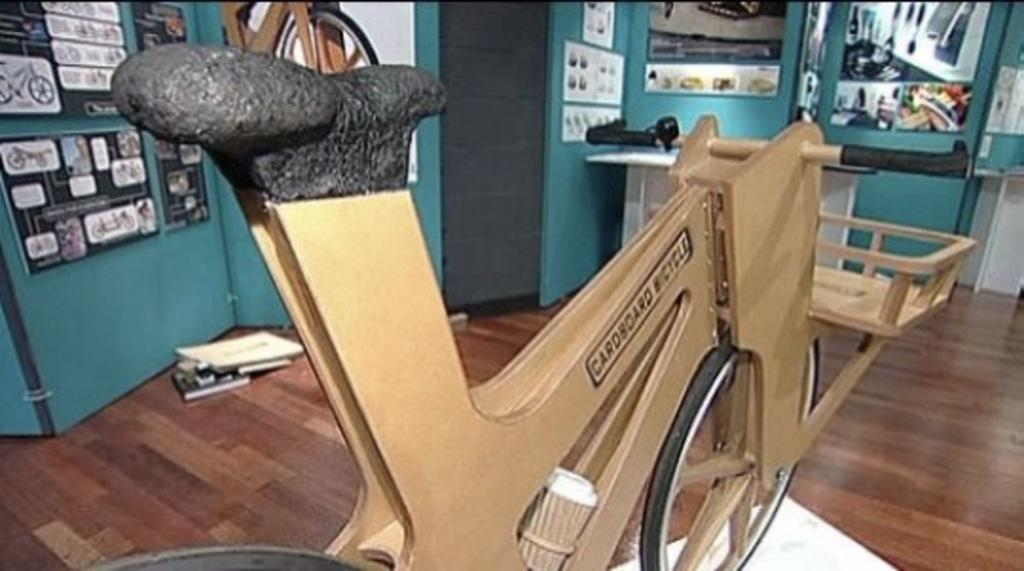What type of bike is depicted in the image? There is a cardboard bike in the image. What other objects can be seen in the image? There are boxes and a desk on the floor in the image. What is on the wall behind the cardboard bike? There are boards on the wall behind the cardboard bike. How do the friends of the toad react to the cardboard bike in the image? There is no mention of friends or a toad in the image, so we cannot determine their reactions. 